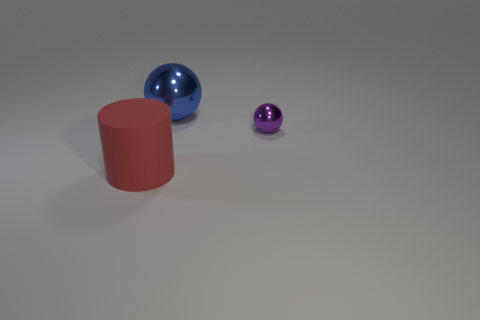What number of blue metallic balls are the same size as the rubber cylinder?
Provide a succinct answer. 1. There is a large thing in front of the metal object on the right side of the big ball; what is its color?
Offer a terse response. Red. Is there a metallic sphere of the same color as the matte cylinder?
Make the answer very short. No. What is the color of the metallic ball that is the same size as the red object?
Your answer should be compact. Blue. Do the sphere that is to the right of the big blue thing and the blue object have the same material?
Offer a terse response. Yes. Are there any objects that are on the left side of the shiny ball in front of the large thing to the right of the red matte object?
Your response must be concise. Yes. There is a big object that is in front of the blue sphere; is its shape the same as the large shiny thing?
Your answer should be compact. No. There is a large object that is behind the red cylinder in front of the tiny metallic ball; what is its shape?
Your answer should be compact. Sphere. There is a metallic ball that is behind the ball in front of the big thing that is behind the big matte thing; what size is it?
Your answer should be very brief. Large. There is another metal object that is the same shape as the big blue metal object; what color is it?
Keep it short and to the point. Purple. 